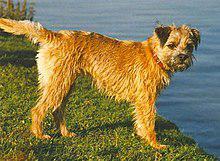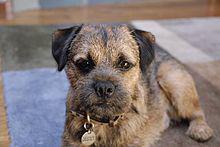The first image is the image on the left, the second image is the image on the right. Analyze the images presented: Is the assertion "The dogs in the images are standing with bodies turned in opposite directions." valid? Answer yes or no. No. 